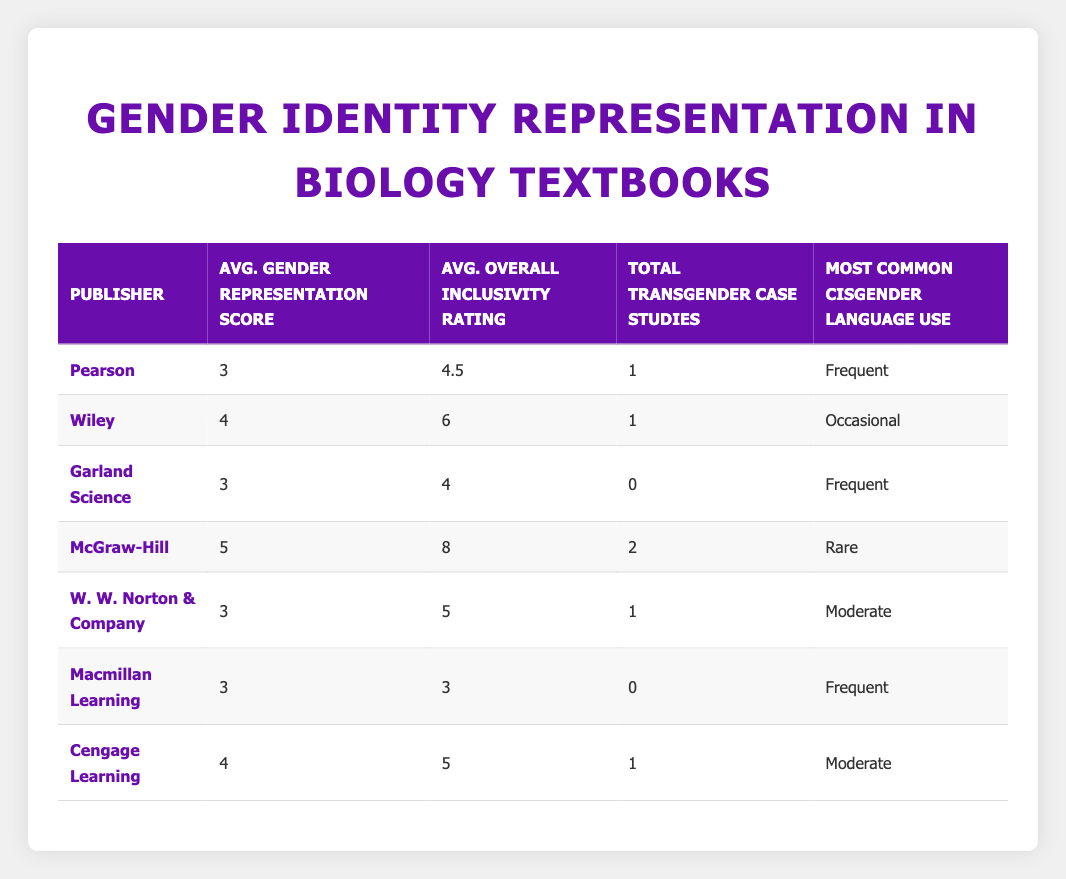What is the average gender representation score for Wiley's textbooks? There is one textbook from Wiley with a gender representation score of 4. Therefore, the average score is simply 4.
Answer: 4 What is the most common cisgender language use for textbooks published by McGraw-Hill? According to the table, the most common cisgender language use for McGraw-Hill is "Rare."
Answer: Rare Which publisher has the highest average overall inclusivity rating? Looking at the table, McGraw-Hill has the highest average overall inclusivity rating of 8.
Answer: McGraw-Hill What is the total number of transgender case studies across all textbooks from Pearson? Pearson has one textbook with 1 transgender case study, so the total number is 1.
Answer: 1 Which publisher has the lowest average gender representation score? Both Garland Science and Macmillan Learning have an average gender representation score of 3, which is the lowest.
Answer: Garland Science and Macmillan Learning What is the difference between the average overall inclusivity rating of Wiley and Cengage Learning? Wiley has an average overall inclusivity rating of 6 and Cengage Learning has 5, so the difference is 6 - 5 = 1.
Answer: 1 Are there any textbooks that include intersex representation published by Pearson? According to the table, Pearson textbooks have "No" intersex inclusion. Therefore, the answer is No.
Answer: No What is the average overall inclusivity rating for textbooks published by Pearson? Pearson has two respondents with overall inclusivity ratings of 3 and 6. To find the average, add them: (3 + 6) / 2 = 4.5.
Answer: 4.5 Which publisher has the most transgender case studies? McGraw-Hill has the highest total of 2 transgender case studies in their textbook compared to other publishers.
Answer: McGraw-Hill 